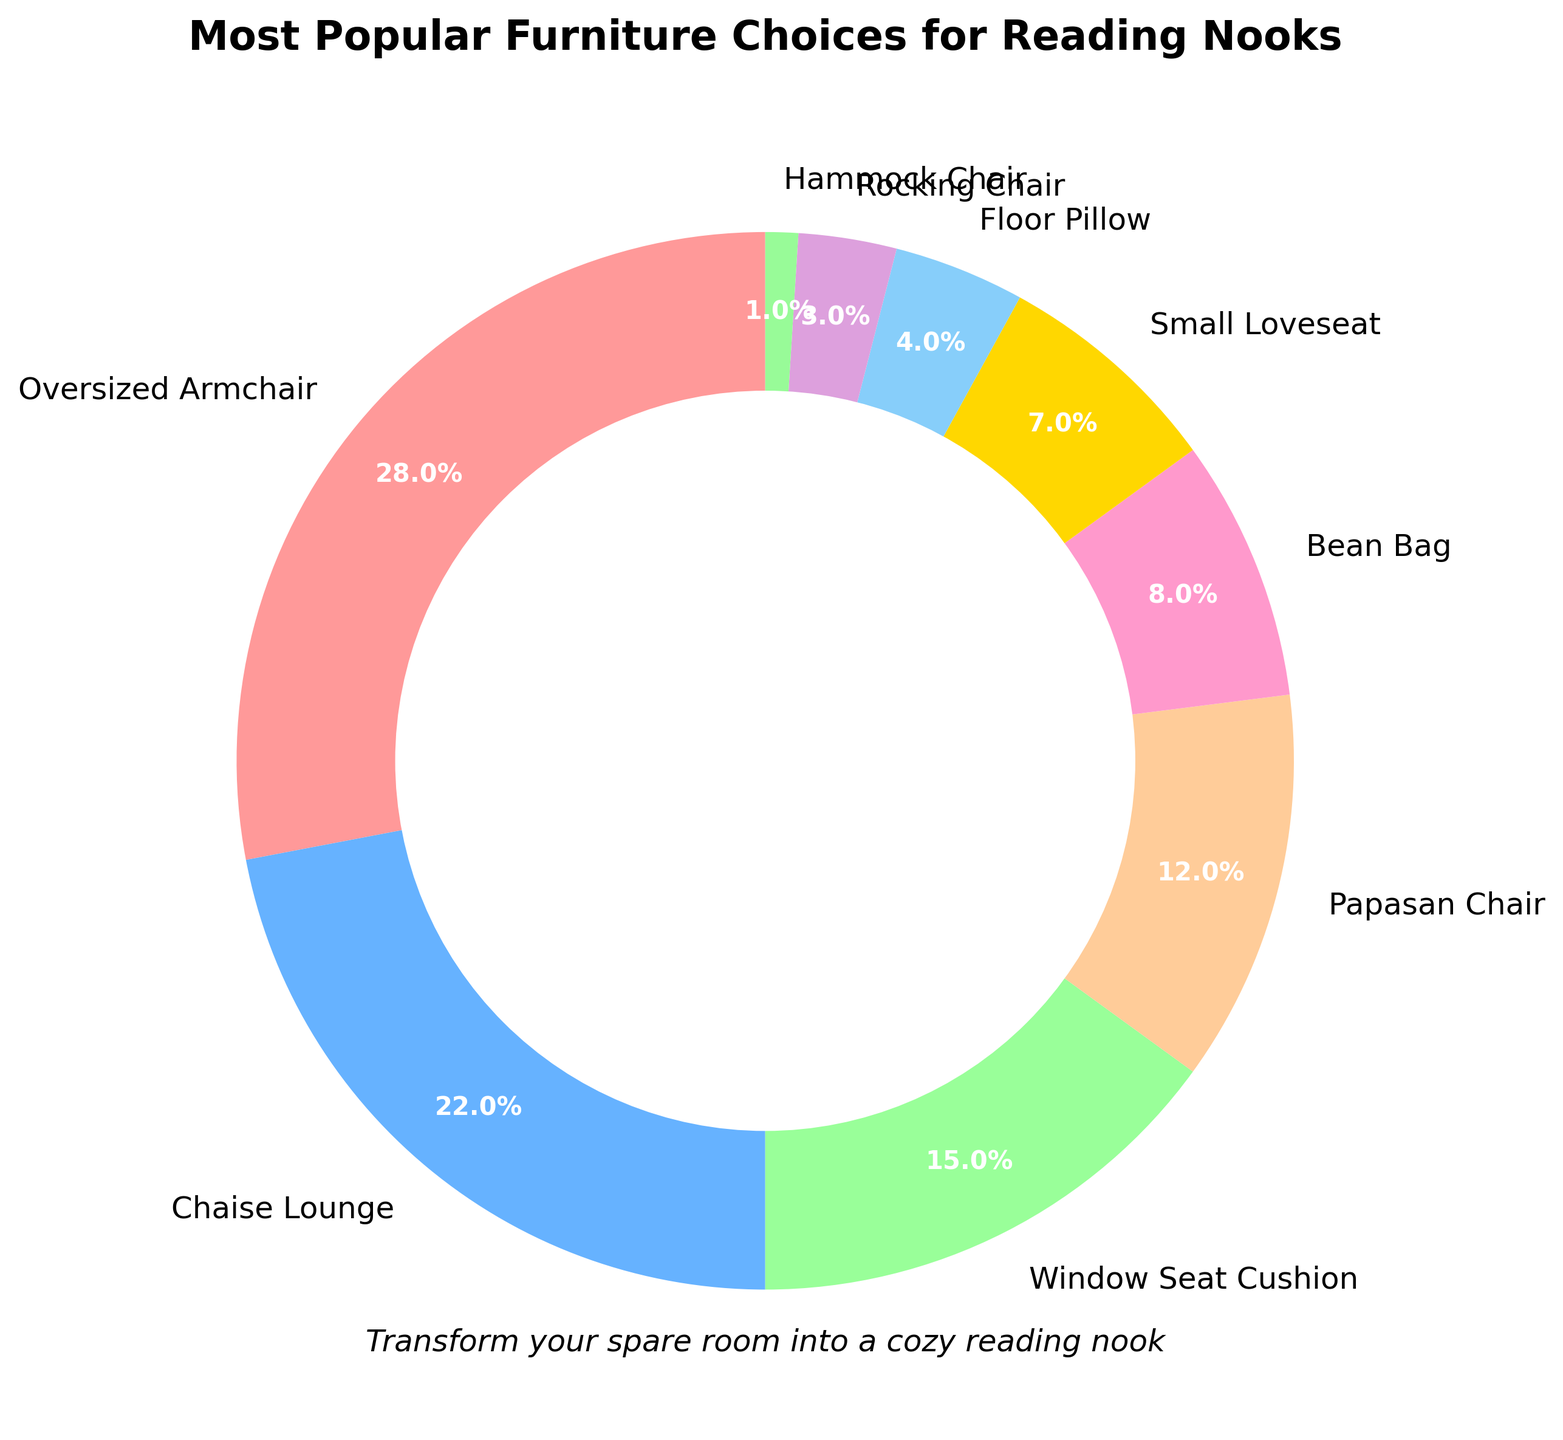What is the most popular furniture choice for a reading nook? The most popular furniture choice for a reading nook, as indicated by the largest slice of the pie chart, is the Oversized Armchair. It occupies 28% of the chart, the highest percentage among the options.
Answer: Oversized Armchair What is the combined percentage of people who prefer either a Chaise Lounge or a Window Seat Cushion? The percentage for Chaise Lounge is 22% and for Window Seat Cushion is 15%. By adding these two percentages, we get 22% + 15% = 37%.
Answer: 37% Which furniture type has a smaller percentage, a Bean Bag or a Papasan Chair? From the pie chart, the Bean Bag has a share of 8%, while the Papasan Chair has a share of 12%. Since 8% is smaller than 12%, the Bean Bag has a smaller percentage.
Answer: Bean Bag What is the total percentage of less popular choices (those with less than 5%)? The percentages of choices with less than 5% are Floor Pillow (4%), Rocking Chair (3%), and Hammock Chair (1%). Adding these together: 4% + 3% + 1% = 8%.
Answer: 8% If you combine the percentages of Floor Pillow and Small Loveseat, how does their combined percentage compare to the percentage of the Window Seat Cushion? The Floor Pillow has 4% and the Small Loveseat has 7%, leading to a combined percentage of 4% + 7% = 11%. The Window Seat Cushion has a percentage of 15%. Since 11% is less than 15%, the combined percentage of the Floor Pillow and Small Loveseat is smaller.
Answer: Smaller Which two furniture types have the closest percentages? By examining the pie chart, the Small Loveseat has 7% and the Bean Bag has 8%. The difference between 7% and 8% is 1%, which is the smallest gap compared to the differences among other types.
Answer: Small Loveseat and Bean Bag What percentage of people chose options other than the Oversized Armchair? The percentage of the Oversized Armchair is 28%. To find the percentage of people who chose other options, subtract this from 100%: 100% - 28% = 72%.
Answer: 72% Compared to the Oversized Armchair, how much smaller is the percentage of the Chaise Lounge? The percentage for the Oversized Armchair is 28%, and for the Chaise Lounge, it is 22%. The difference is 28% - 22% = 6%.
Answer: 6% What are the top three furniture choices for a reading nook? The top three furniture choices, as indicated by the largest percentages, are the Oversized Armchair (28%), Chaise Lounge (22%), and Window Seat Cushion (15%).
Answer: Oversized Armchair, Chaise Lounge, Window Seat Cushion 